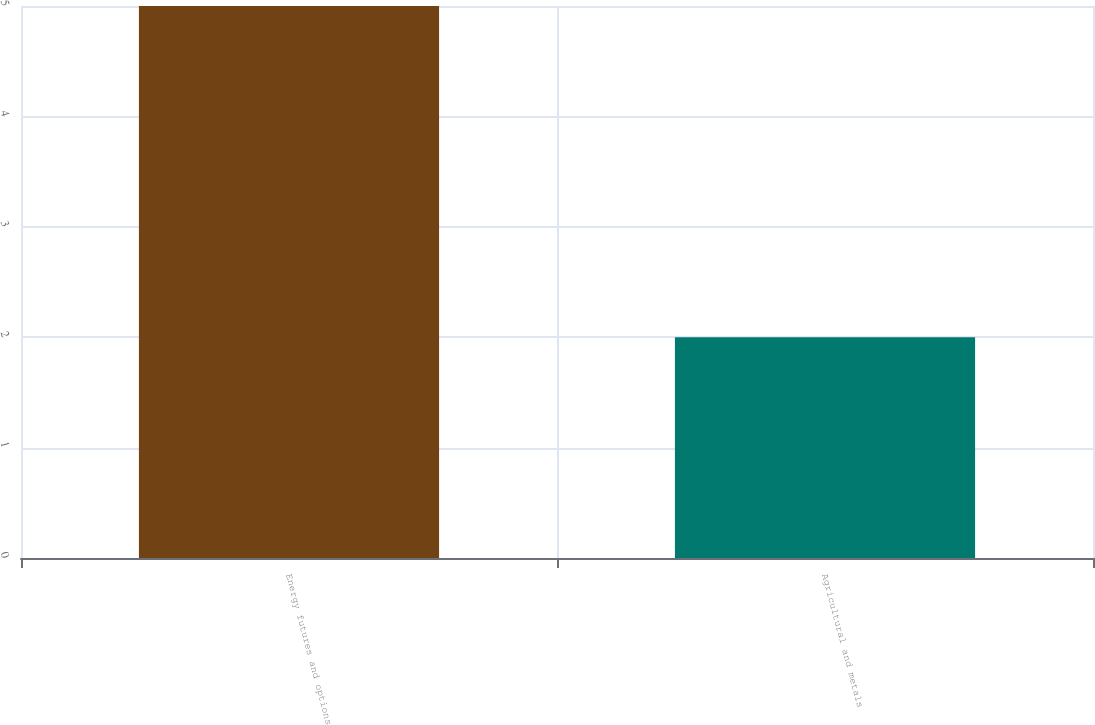Convert chart. <chart><loc_0><loc_0><loc_500><loc_500><bar_chart><fcel>Energy futures and options<fcel>Agricultural and metals<nl><fcel>5<fcel>2<nl></chart> 